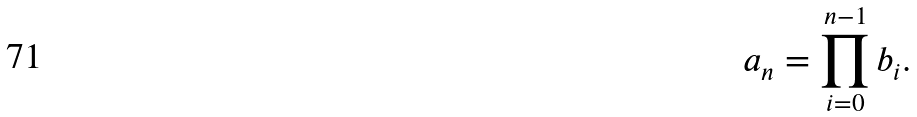<formula> <loc_0><loc_0><loc_500><loc_500>a _ { n } = \prod _ { i = 0 } ^ { n - 1 } b _ { i } .</formula> 